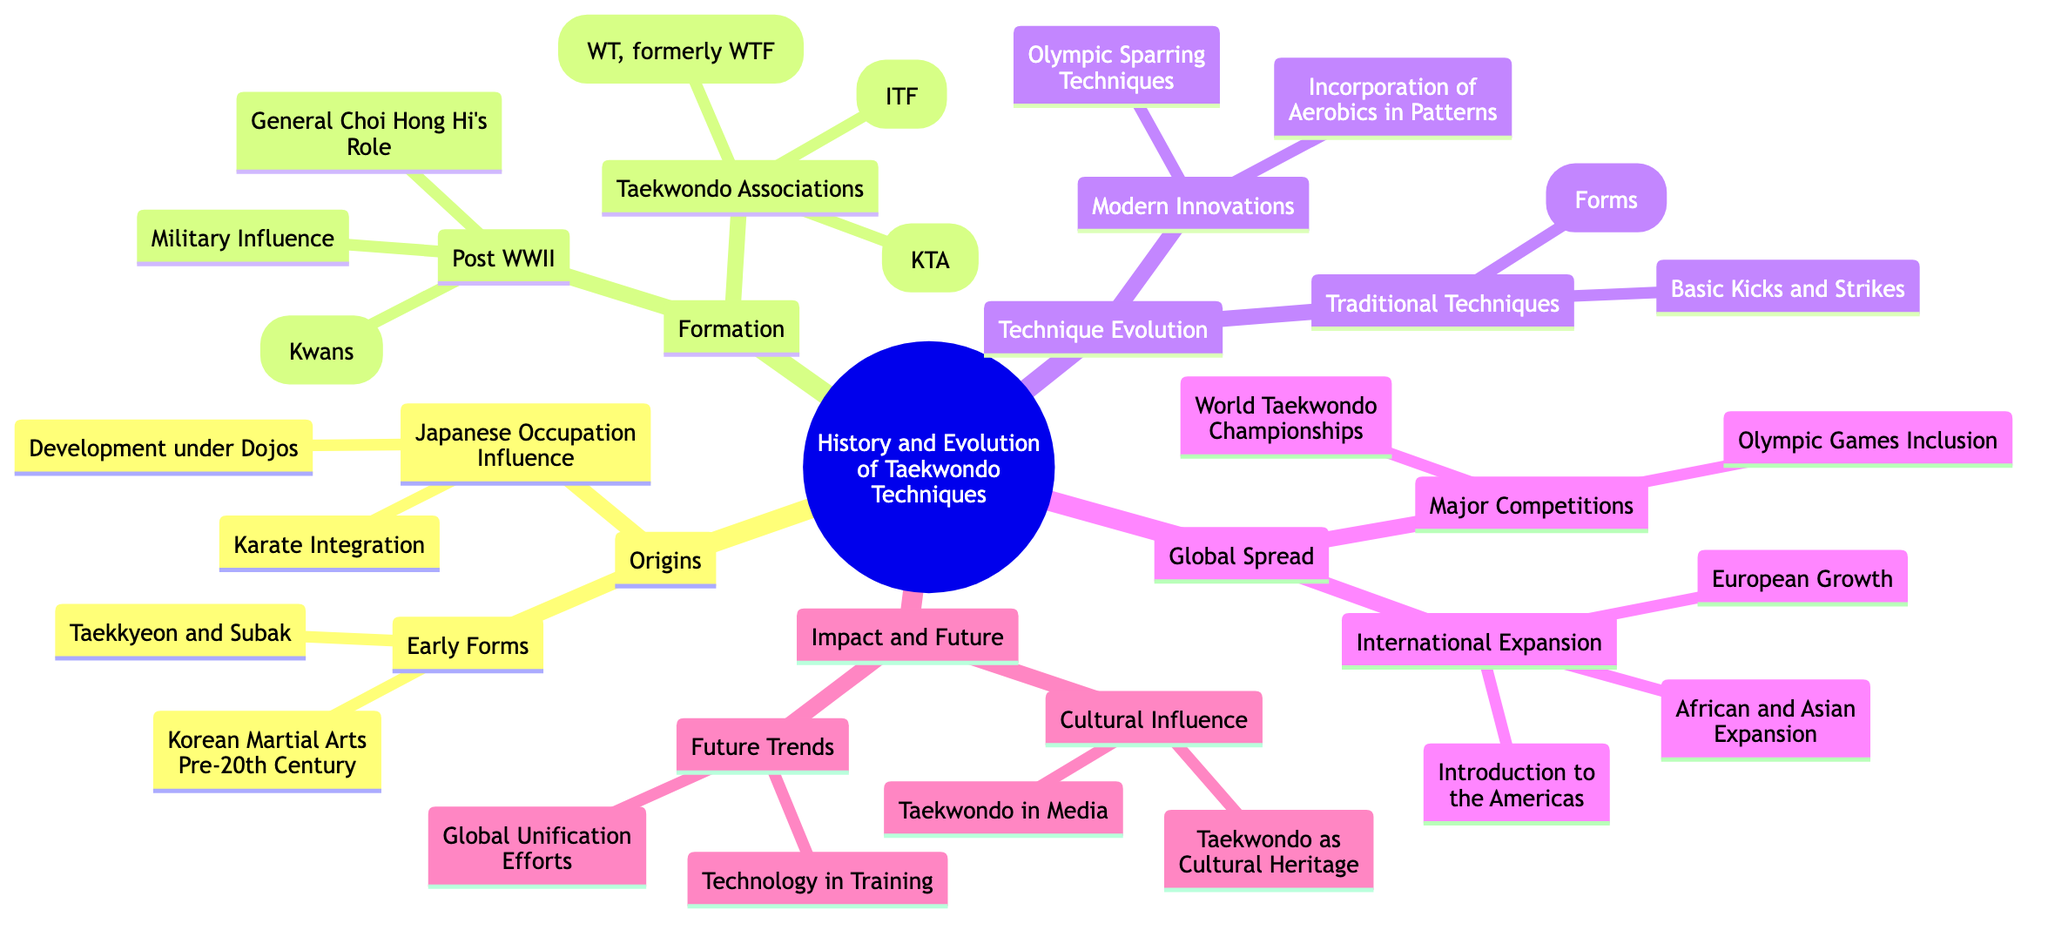What is the central topic of the Mind Map? The central topic is clearly labeled in the center of the diagram as "History and Evolution of Taekwondo Techniques."
Answer: History and Evolution of Taekwondo Techniques How many main branches are there in the Mind Map? By counting the distinct main branches that extend from the central topic, there are five: Origins, Formation, Technique Evolution, Global Spread, and Impact and Future.
Answer: 5 What are the two sub-branches under the "Origins" branch? The two sub-branches under "Origins" are "Early Forms" and "Japanese Occupation Influence."
Answer: Early Forms, Japanese Occupation Influence Which technique is categorized as a modern innovation in Taekwondo? The modern innovations listed include "Olympic Sparring Techniques" and "Incorporation of Aerobics in Patterns," with both being significant advancements in technique.
Answer: Olympic Sparring Techniques Who played a key role in the post-WWII formation of Taekwondo? The diagram specifically mentions "General Choi Hong Hi’s Role" as a key figure in the unification and formation of Taekwondo during that time.
Answer: General Choi Hong Hi's Role What connection exists between the "International Expansion" and "Major Competitions" sections? The two sections are both part of the same main branch "Global Spread," indicating that they are related aspects of Taekwondo's global development and outreach.
Answer: Global Spread What is noted as a future trend in the Mind Map? The future trends mentioned focus on "Technology in Training" and "Global Unification Efforts," highlighting anticipated advancements and movements in Taekwondo.
Answer: Technology in Training What role did the military play in the formation of Taekwondo? The diagram identifies "Military Influence" as a notable element in the post-WWII formation, suggesting it had a significant impact during that time.
Answer: Military Influence How many organizations are mentioned under "Taekwondo Associations"? Three organizations are directly stated under this branch: "Korea Taekwondo Association (KTA)," "International Taekwondo Federation (ITF)," and "World Taekwondo (WT, formerly WTF)."
Answer: 3 